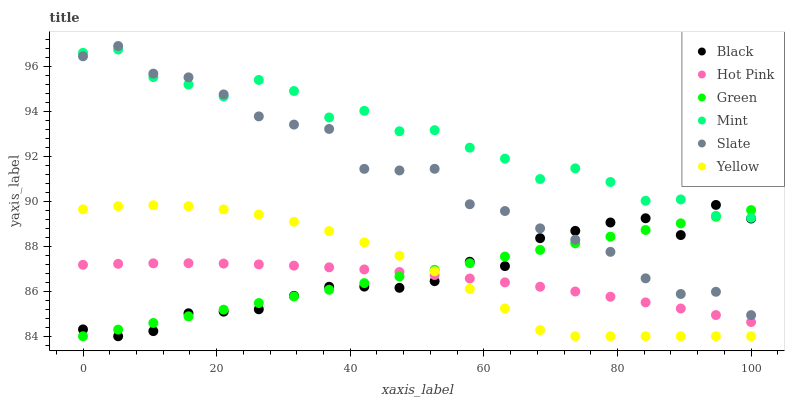Does Hot Pink have the minimum area under the curve?
Answer yes or no. Yes. Does Mint have the maximum area under the curve?
Answer yes or no. Yes. Does Yellow have the minimum area under the curve?
Answer yes or no. No. Does Yellow have the maximum area under the curve?
Answer yes or no. No. Is Green the smoothest?
Answer yes or no. Yes. Is Mint the roughest?
Answer yes or no. Yes. Is Hot Pink the smoothest?
Answer yes or no. No. Is Hot Pink the roughest?
Answer yes or no. No. Does Yellow have the lowest value?
Answer yes or no. Yes. Does Hot Pink have the lowest value?
Answer yes or no. No. Does Slate have the highest value?
Answer yes or no. Yes. Does Yellow have the highest value?
Answer yes or no. No. Is Hot Pink less than Mint?
Answer yes or no. Yes. Is Mint greater than Hot Pink?
Answer yes or no. Yes. Does Black intersect Slate?
Answer yes or no. Yes. Is Black less than Slate?
Answer yes or no. No. Is Black greater than Slate?
Answer yes or no. No. Does Hot Pink intersect Mint?
Answer yes or no. No. 